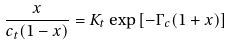Convert formula to latex. <formula><loc_0><loc_0><loc_500><loc_500>\frac { x } { c _ { t } ( 1 - x ) } = K _ { t } \exp \left [ - \Gamma _ { c } ( 1 + x ) \right ]</formula> 